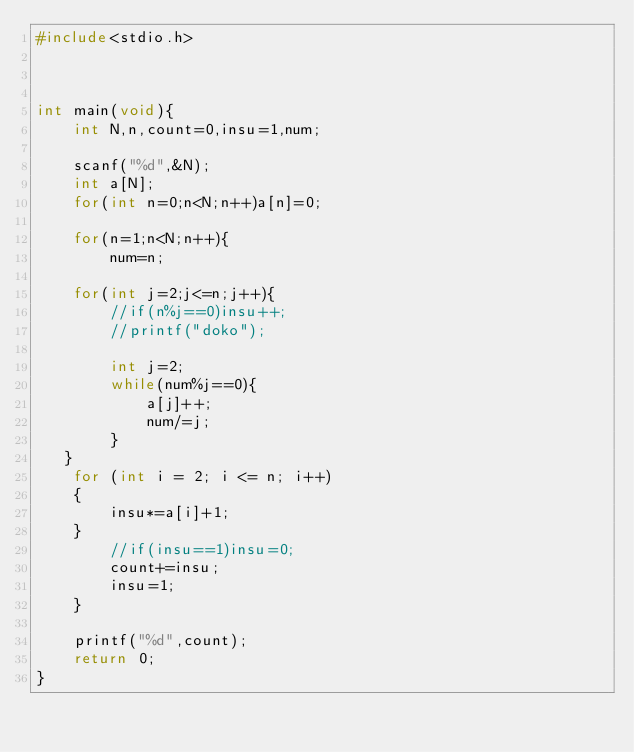<code> <loc_0><loc_0><loc_500><loc_500><_C_>#include<stdio.h>



int main(void){
    int N,n,count=0,insu=1,num;

    scanf("%d",&N);
    int a[N];
    for(int n=0;n<N;n++)a[n]=0;

    for(n=1;n<N;n++){
        num=n;

    for(int j=2;j<=n;j++){
        //if(n%j==0)insu++;
        //printf("doko");

        int j=2;
        while(num%j==0){
            a[j]++;
            num/=j;
        }
   }
    for (int i = 2; i <= n; i++)
	{	
		insu*=a[i]+1;
	}
        //if(insu==1)insu=0;
        count+=insu;
        insu=1;
    }

    printf("%d",count);
    return 0;
}</code> 